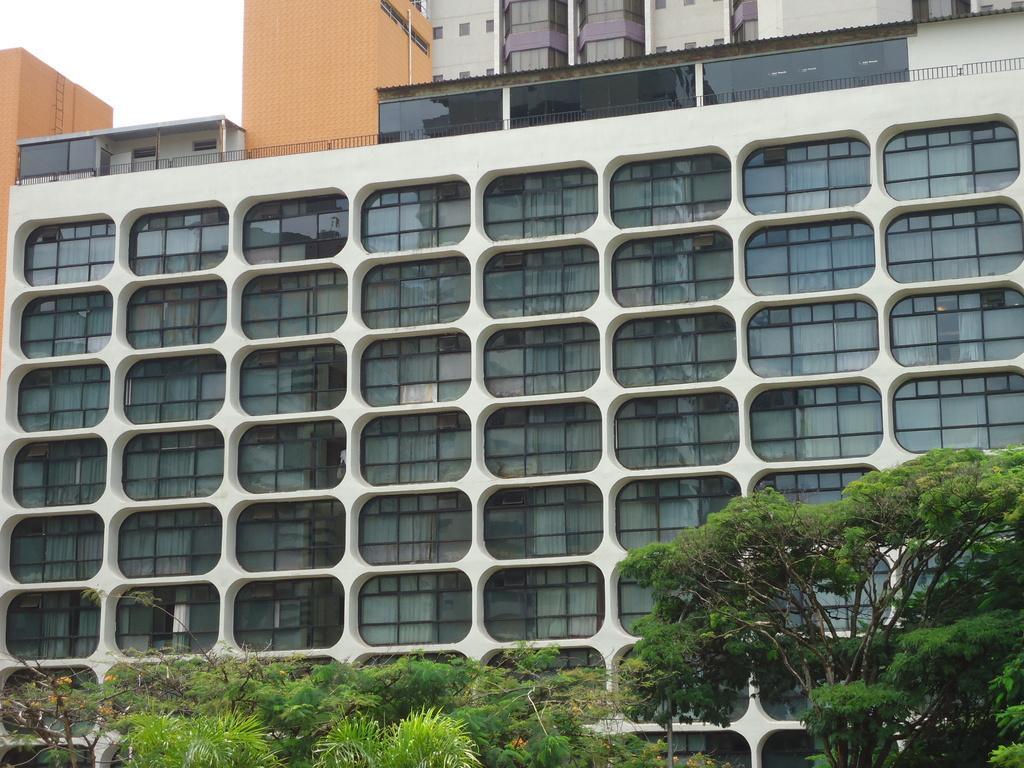How would you summarize this image in a sentence or two? In this image we can see the buildings, trees and also the sky. 